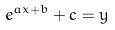<formula> <loc_0><loc_0><loc_500><loc_500>e ^ { a x + b } + c = y</formula> 